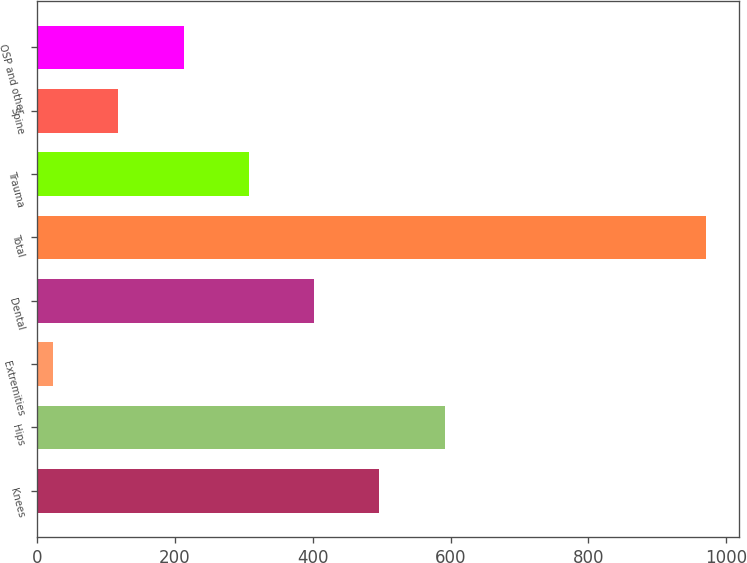Convert chart to OTSL. <chart><loc_0><loc_0><loc_500><loc_500><bar_chart><fcel>Knees<fcel>Hips<fcel>Extremities<fcel>Dental<fcel>Total<fcel>Trauma<fcel>Spine<fcel>OSP and other<nl><fcel>496.85<fcel>591.58<fcel>23.2<fcel>402.12<fcel>970.5<fcel>307.39<fcel>117.93<fcel>212.66<nl></chart> 